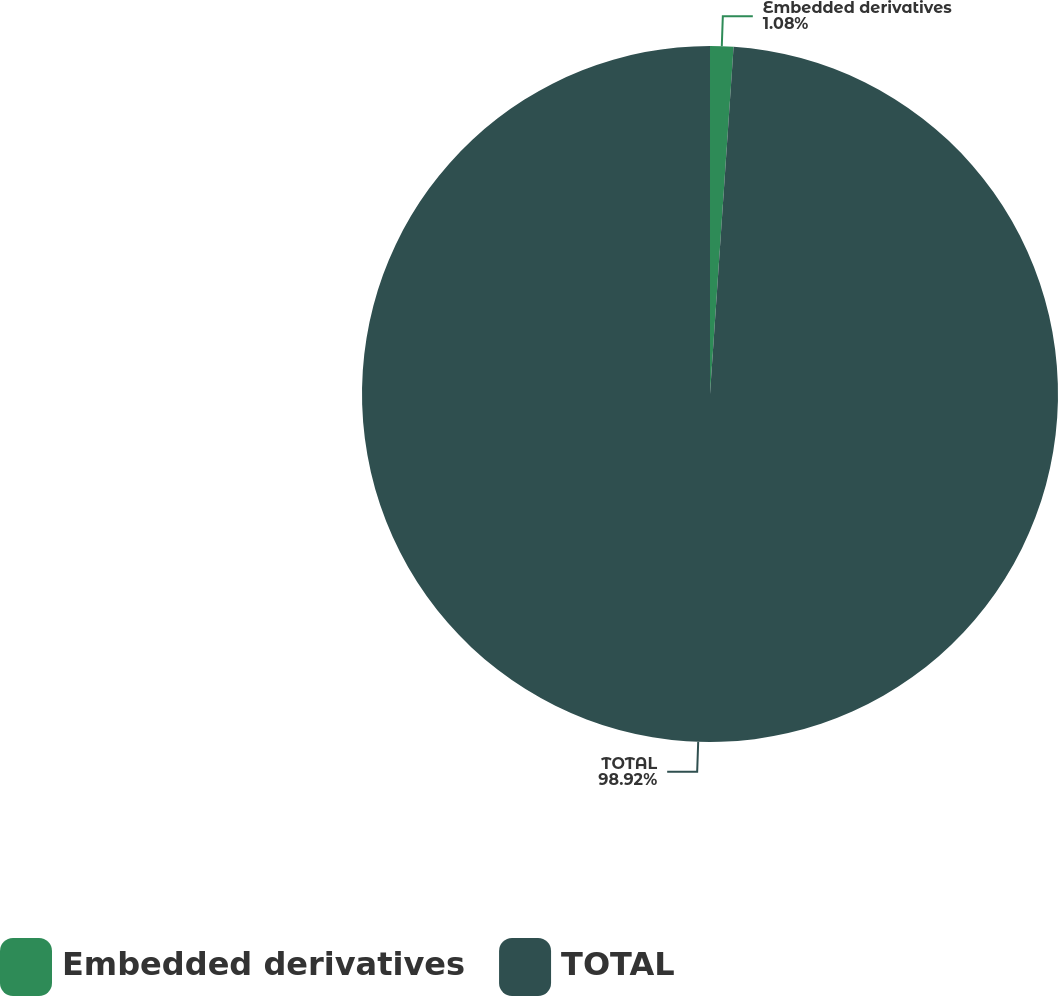Convert chart to OTSL. <chart><loc_0><loc_0><loc_500><loc_500><pie_chart><fcel>Embedded derivatives<fcel>TOTAL<nl><fcel>1.08%<fcel>98.92%<nl></chart> 